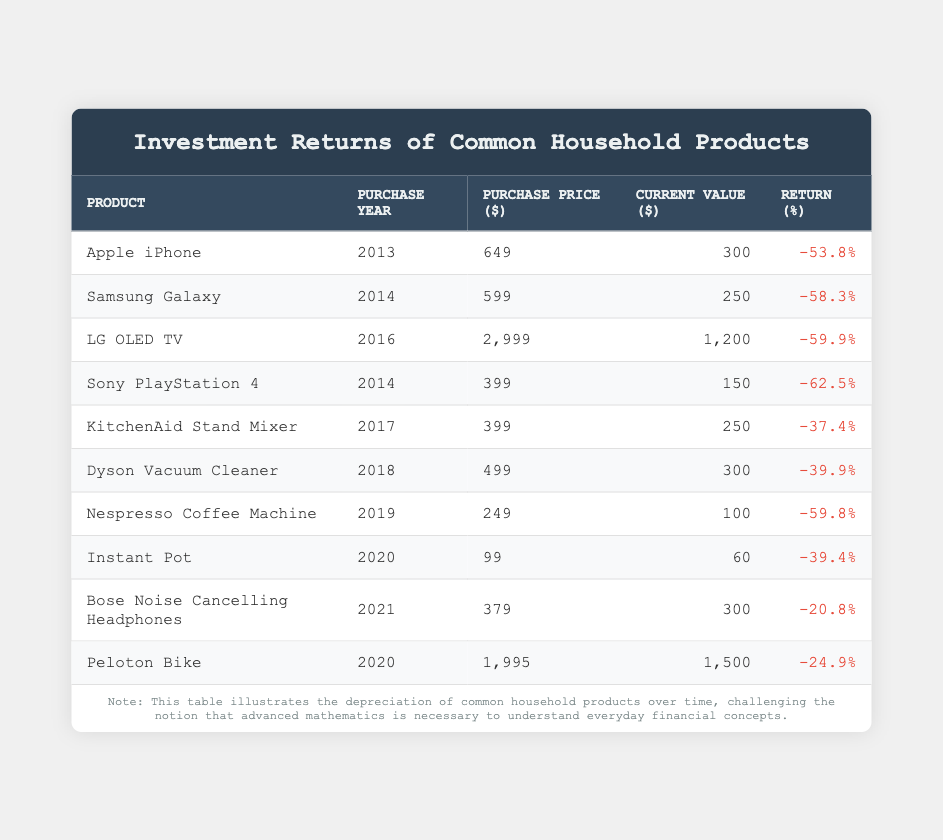What was the purchase price of the LG OLED TV? From the table, we can directly refer to the row for the LG OLED TV, which shows the purchase price as 2999.
Answer: 2999 What percentage return did the Dyson Vacuum Cleaner have? The Dyson Vacuum Cleaner row in the table states the return percentage as -39.9.
Answer: -39.9 Which product had the lowest current value? By examining the current value column across all products, the Nespresso Coffee Machine has the lowest current value at 100.
Answer: 100 What is the average purchase price of the products listed? The purchase prices are: 649, 599, 2999, 399, 399, 499, 249, 99, 379, 1995. Summing these gives 4802. There are 10 products, so the average is 4802 divided by 10 = 480.2.
Answer: 480.2 Did any product appreciate over time? By reviewing the return percentage column, all products have a negative return percentage, indicating none have appreciated.
Answer: No Which product has the highest return percentage? The return percentage for the products are: -53.8, -58.3, -59.9, -62.5, -37.4, -39.9, -59.8, -39.4, -20.8, -24.9. The highest (least negative) value is -20.8 from the Bose Noise Cancelling Headphones.
Answer: -20.8 What is the total current value of all the products listed? The current values are 300, 250, 1200, 150, 250, 300, 100, 60, 300, 1500. Summing these yields 1500 + 300 + 100 + 60 + 300 + 250 + 150 + 1200 + 250 = 2610.
Answer: 2610 Which product had the earliest purchase year? Looking at the purchase year column, the Apple iPhone, purchased in 2013, is the earliest among the entries.
Answer: 2013 What is the difference in current value between the Peloton Bike and the Nespresso Coffee Machine? The current value for the Peloton Bike is 1500 and for the Nespresso Coffee Machine is 100. The difference is 1500 - 100 = 1400.
Answer: 1400 